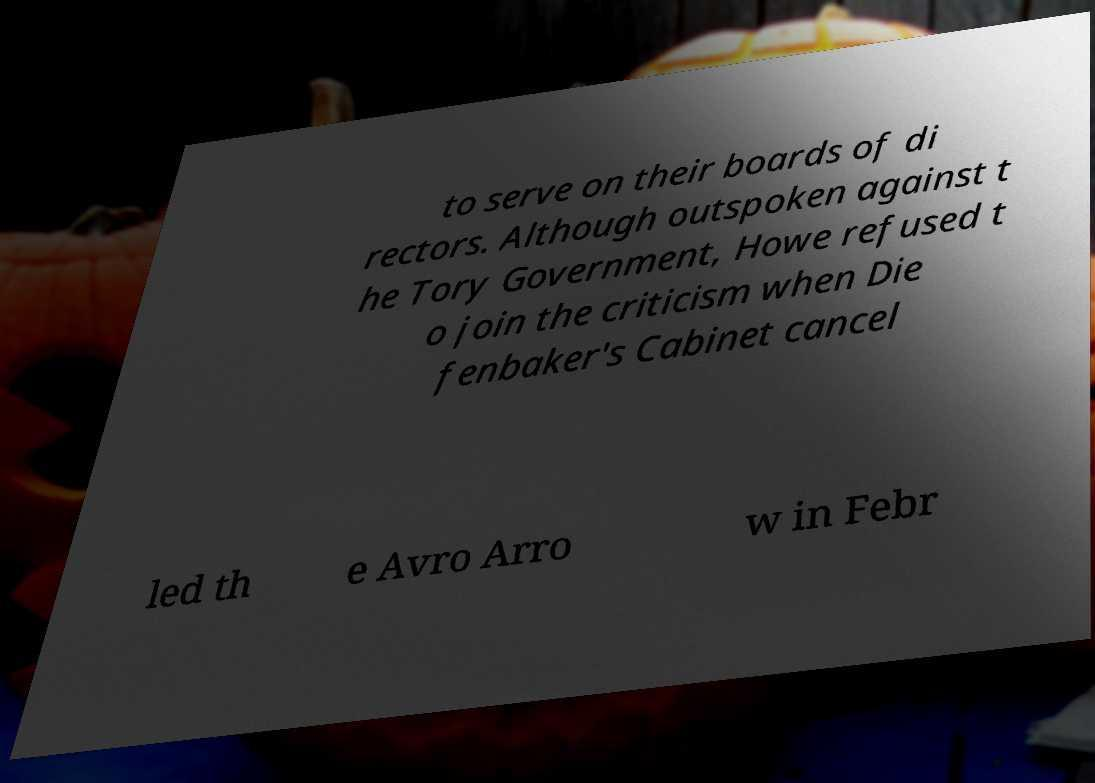Please read and relay the text visible in this image. What does it say? to serve on their boards of di rectors. Although outspoken against t he Tory Government, Howe refused t o join the criticism when Die fenbaker's Cabinet cancel led th e Avro Arro w in Febr 